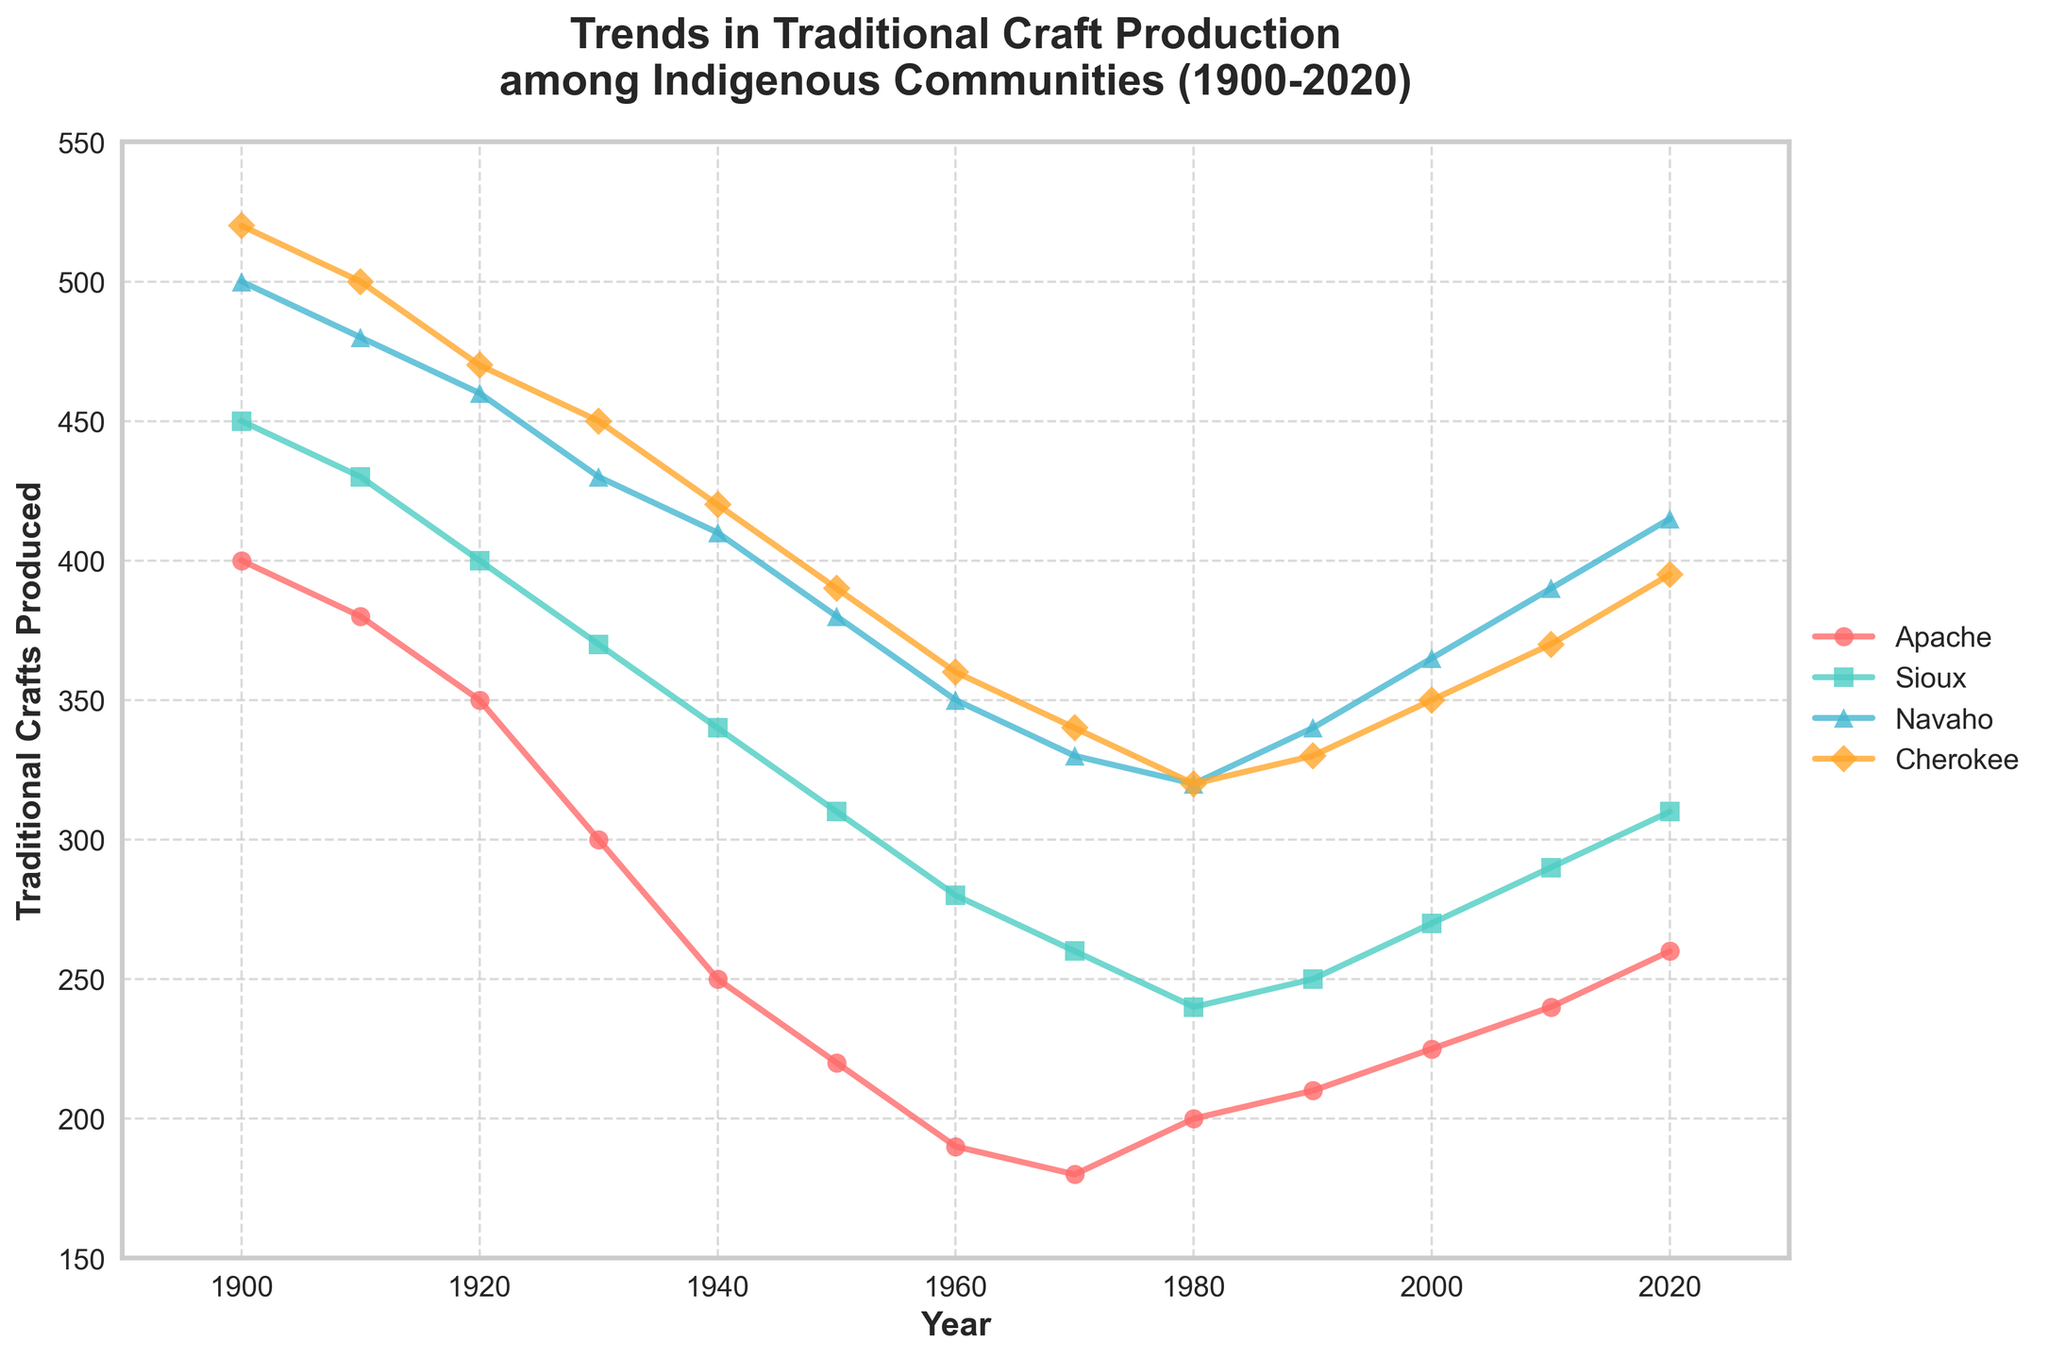What is the title of the plot? The title of the plot is the text displayed at the top, summarizing what the figure is about.
Answer: Trends in Traditional Craft Production among Indigenous Communities (1900-2020) How many communities are represented in the plot? Identify the unique groups shown in the legend of the figure, each represented by a different colored line.
Answer: Four Which community had the highest traditional crafts production in 1920? Locate the year 1920 on the x-axis, then follow vertically to see which line (and corresponding community) had the highest y-value.
Answer: Cherokee By how much did the traditional crafts production for the Apache community change from 1900 to 1930? Find the y-value for the Apache community at 1900 and 1930, then subtract the latter from the former.
Answer: 100 (400 - 300) Between which consecutive decades did the Sioux community experience the largest decrease in traditional crafts production? Compare the drops in production for each consecutive decade by observing changes in the slope of the Sioux line, finding where it is steepest.
Answer: 1940 to 1950 What trend can be observed in the traditional crafts production for the Navaho community from 1980 to 2020? Look at the Navaho line from 1980 to 2020 to identify a trend, whether it features an increase, decrease, or stability.
Answer: Increasing Which two communities had the closest level of traditional crafts production in the year 2000? For the year 2000, find the y-values for all communities and determine which two values are nearest each other.
Answer: Apache and Sioux What was the approximate combined traditional crafts production for all communities in 2010? Find the y-values for all communities in 2010 and sum them.
Answer: 1290 (240 for Apache + 290 for Sioux + 390 for Navaho + 370 for Cherokee) In which year did the Cherokee community's traditional crafts production start to increase again after a period of decline? Find the downward trend for the Cherokee community on the plot, then locate the year where this trend reverses to an upward slope.
Answer: 1990 Which community experienced a re-increase in traditional craft production sooner, the Apache or Sioux, and in what year did it occur for them? Find the year each community started to increase again (following a decline period) and compare the years.
Answer: Apache in 1980 